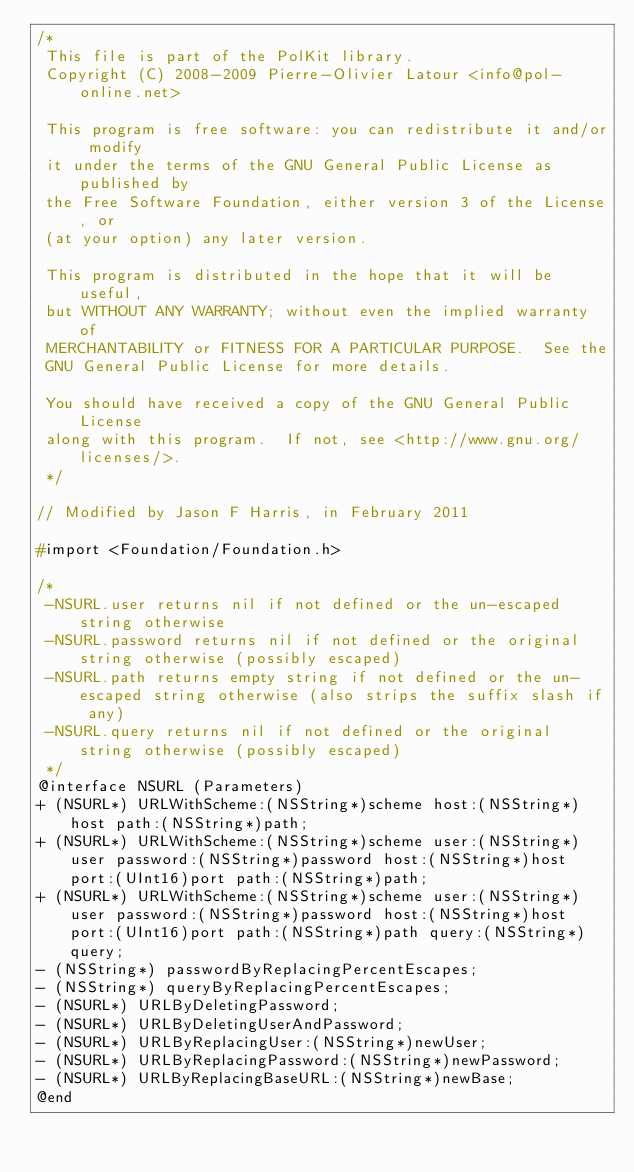<code> <loc_0><loc_0><loc_500><loc_500><_C_>/*
 This file is part of the PolKit library.
 Copyright (C) 2008-2009 Pierre-Olivier Latour <info@pol-online.net>
 
 This program is free software: you can redistribute it and/or modify
 it under the terms of the GNU General Public License as published by
 the Free Software Foundation, either version 3 of the License, or
 (at your option) any later version.
 
 This program is distributed in the hope that it will be useful,
 but WITHOUT ANY WARRANTY; without even the implied warranty of
 MERCHANTABILITY or FITNESS FOR A PARTICULAR PURPOSE.  See the
 GNU General Public License for more details.
 
 You should have received a copy of the GNU General Public License
 along with this program.  If not, see <http://www.gnu.org/licenses/>.
 */

// Modified by Jason F Harris, in February 2011

#import <Foundation/Foundation.h>

/*
 -NSURL.user returns nil if not defined or the un-escaped string otherwise
 -NSURL.password returns nil if not defined or the original string otherwise (possibly escaped)
 -NSURL.path returns empty string if not defined or the un-escaped string otherwise (also strips the suffix slash if any)
 -NSURL.query returns nil if not defined or the original string otherwise (possibly escaped)
 */
@interface NSURL (Parameters)
+ (NSURL*) URLWithScheme:(NSString*)scheme host:(NSString*)host path:(NSString*)path;
+ (NSURL*) URLWithScheme:(NSString*)scheme user:(NSString*)user password:(NSString*)password host:(NSString*)host port:(UInt16)port path:(NSString*)path;
+ (NSURL*) URLWithScheme:(NSString*)scheme user:(NSString*)user password:(NSString*)password host:(NSString*)host port:(UInt16)port path:(NSString*)path query:(NSString*)query;
- (NSString*) passwordByReplacingPercentEscapes;
- (NSString*) queryByReplacingPercentEscapes;
- (NSURL*) URLByDeletingPassword;
- (NSURL*) URLByDeletingUserAndPassword;
- (NSURL*) URLByReplacingUser:(NSString*)newUser;
- (NSURL*) URLByReplacingPassword:(NSString*)newPassword;
- (NSURL*) URLByReplacingBaseURL:(NSString*)newBase;
@end</code> 